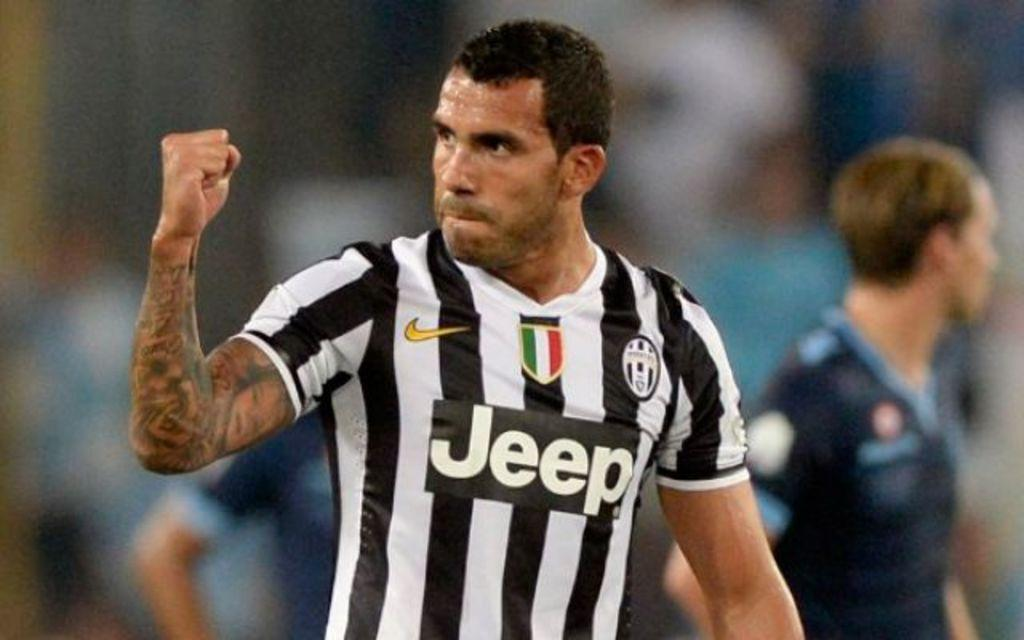<image>
Share a concise interpretation of the image provided. Playing in a shirt sponsored by both Jeep and Nike, the player raises his fist in the air. 